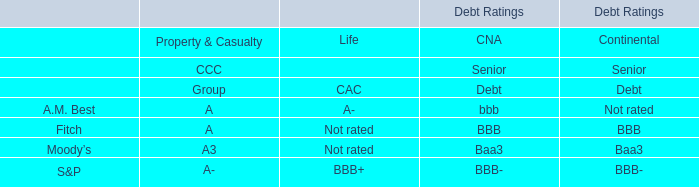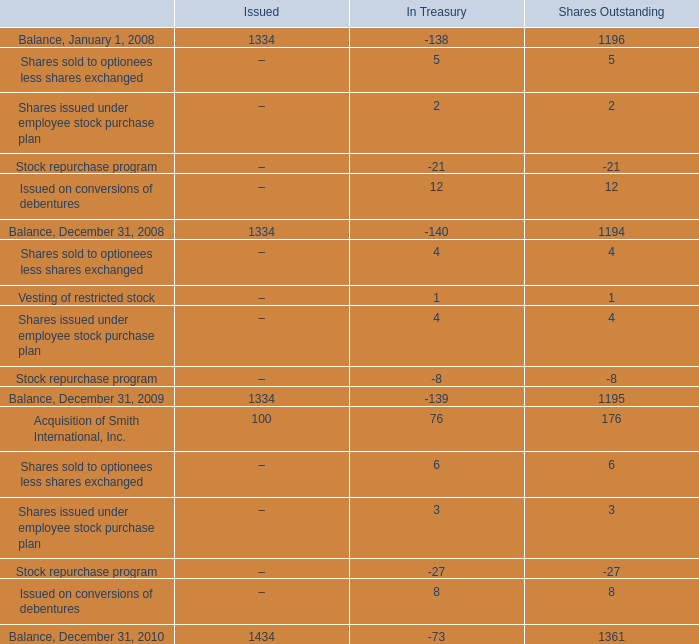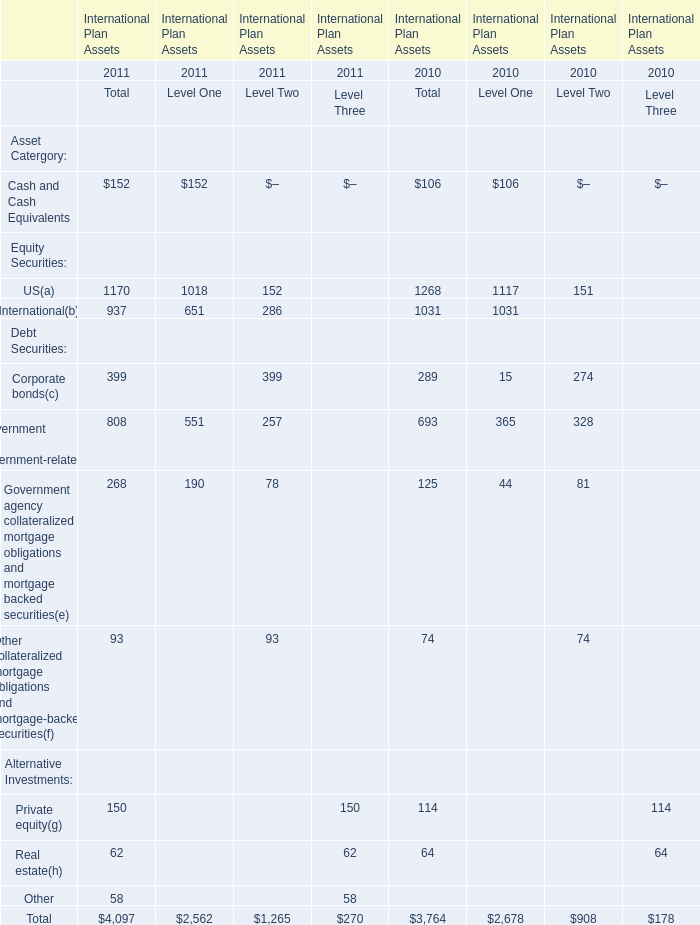What's the total value of all elements for Total that are in the range of 600 and 1300 in 2010? 
Computations: ((1268 + 1031) + 693)
Answer: 2992.0. 